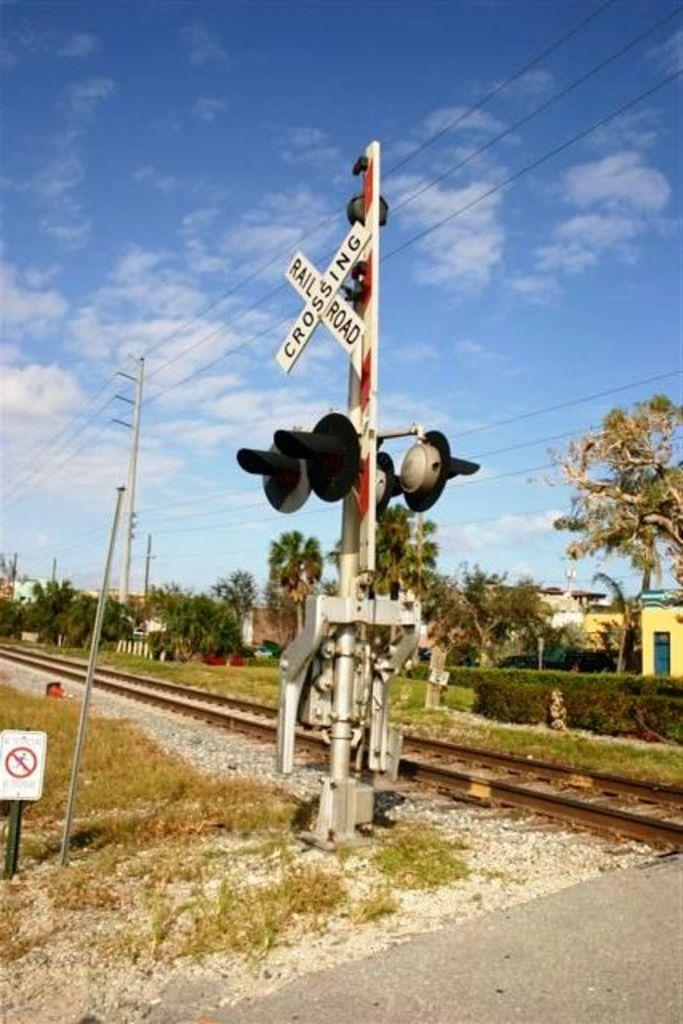Provide a one-sentence caption for the provided image. A railroad track has a sign on white slates that reads Railroad Crossing.". 